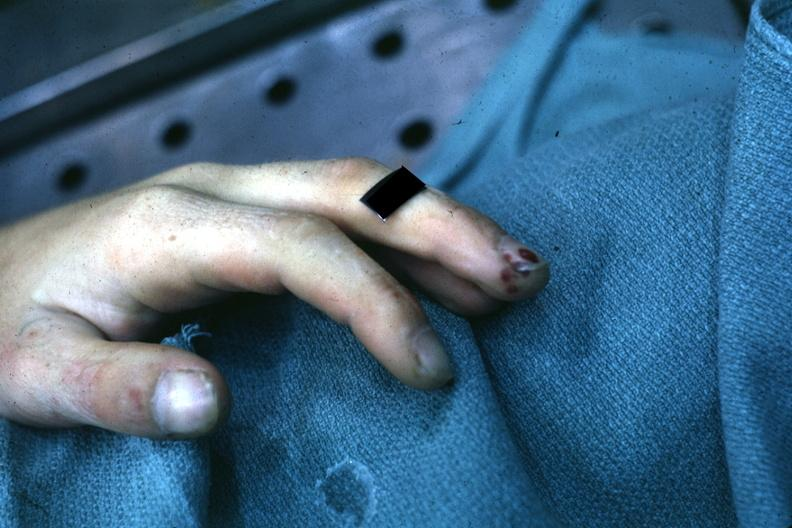what is present?
Answer the question using a single word or phrase. Gangrene 